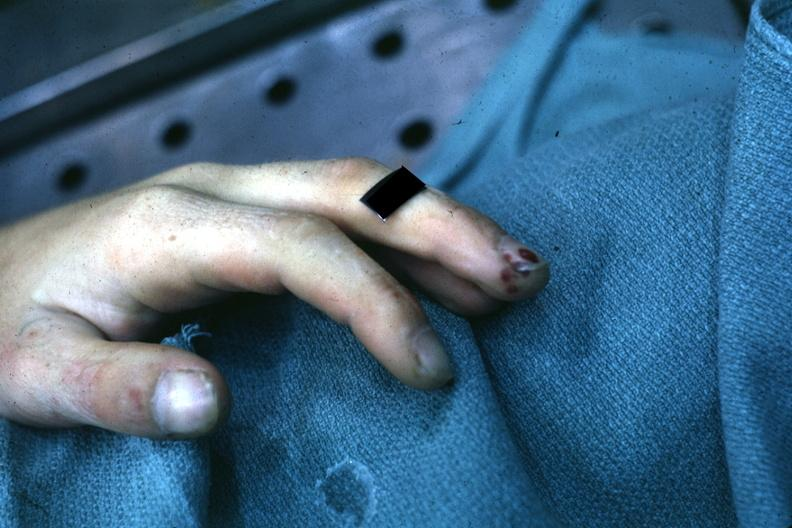what is present?
Answer the question using a single word or phrase. Gangrene 